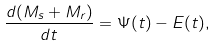Convert formula to latex. <formula><loc_0><loc_0><loc_500><loc_500>\frac { d ( M _ { s } + M _ { r } ) } { d t } = \Psi ( t ) - E ( t ) ,</formula> 